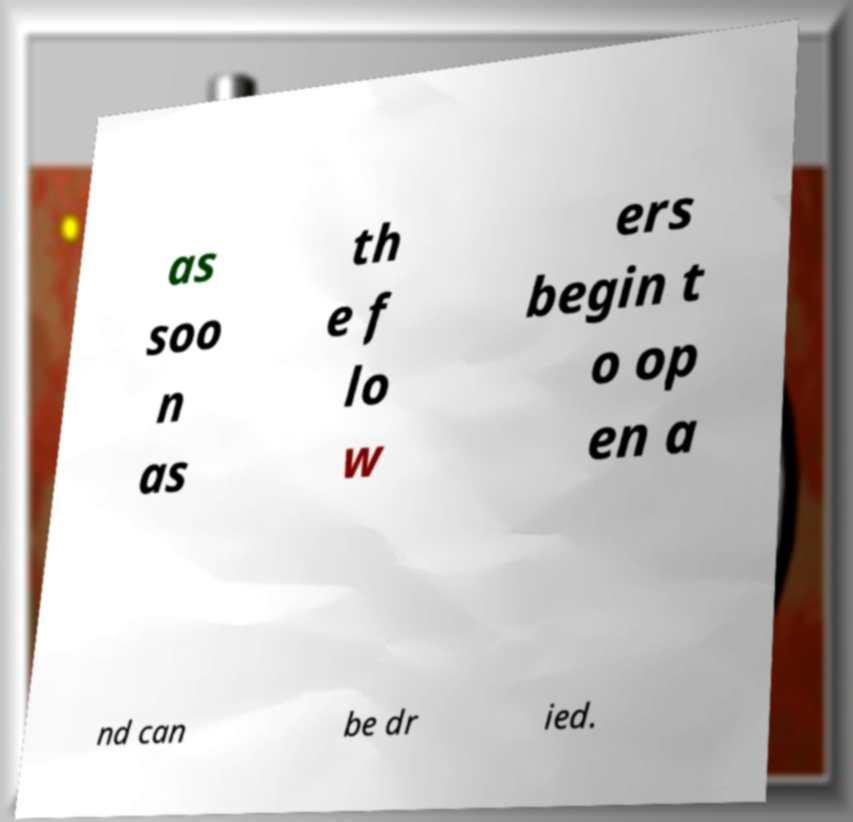What messages or text are displayed in this image? I need them in a readable, typed format. as soo n as th e f lo w ers begin t o op en a nd can be dr ied. 